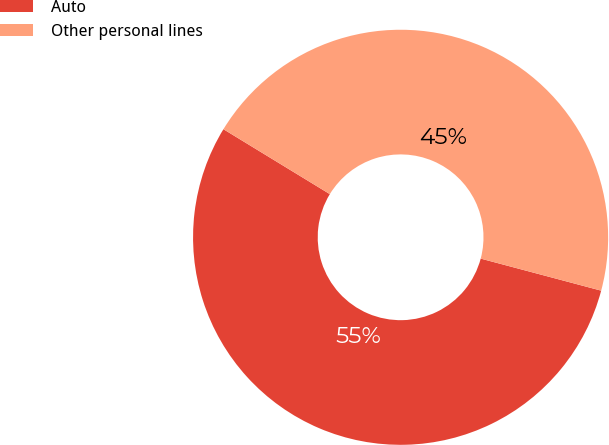Convert chart to OTSL. <chart><loc_0><loc_0><loc_500><loc_500><pie_chart><fcel>Auto<fcel>Other personal lines<nl><fcel>54.58%<fcel>45.42%<nl></chart> 